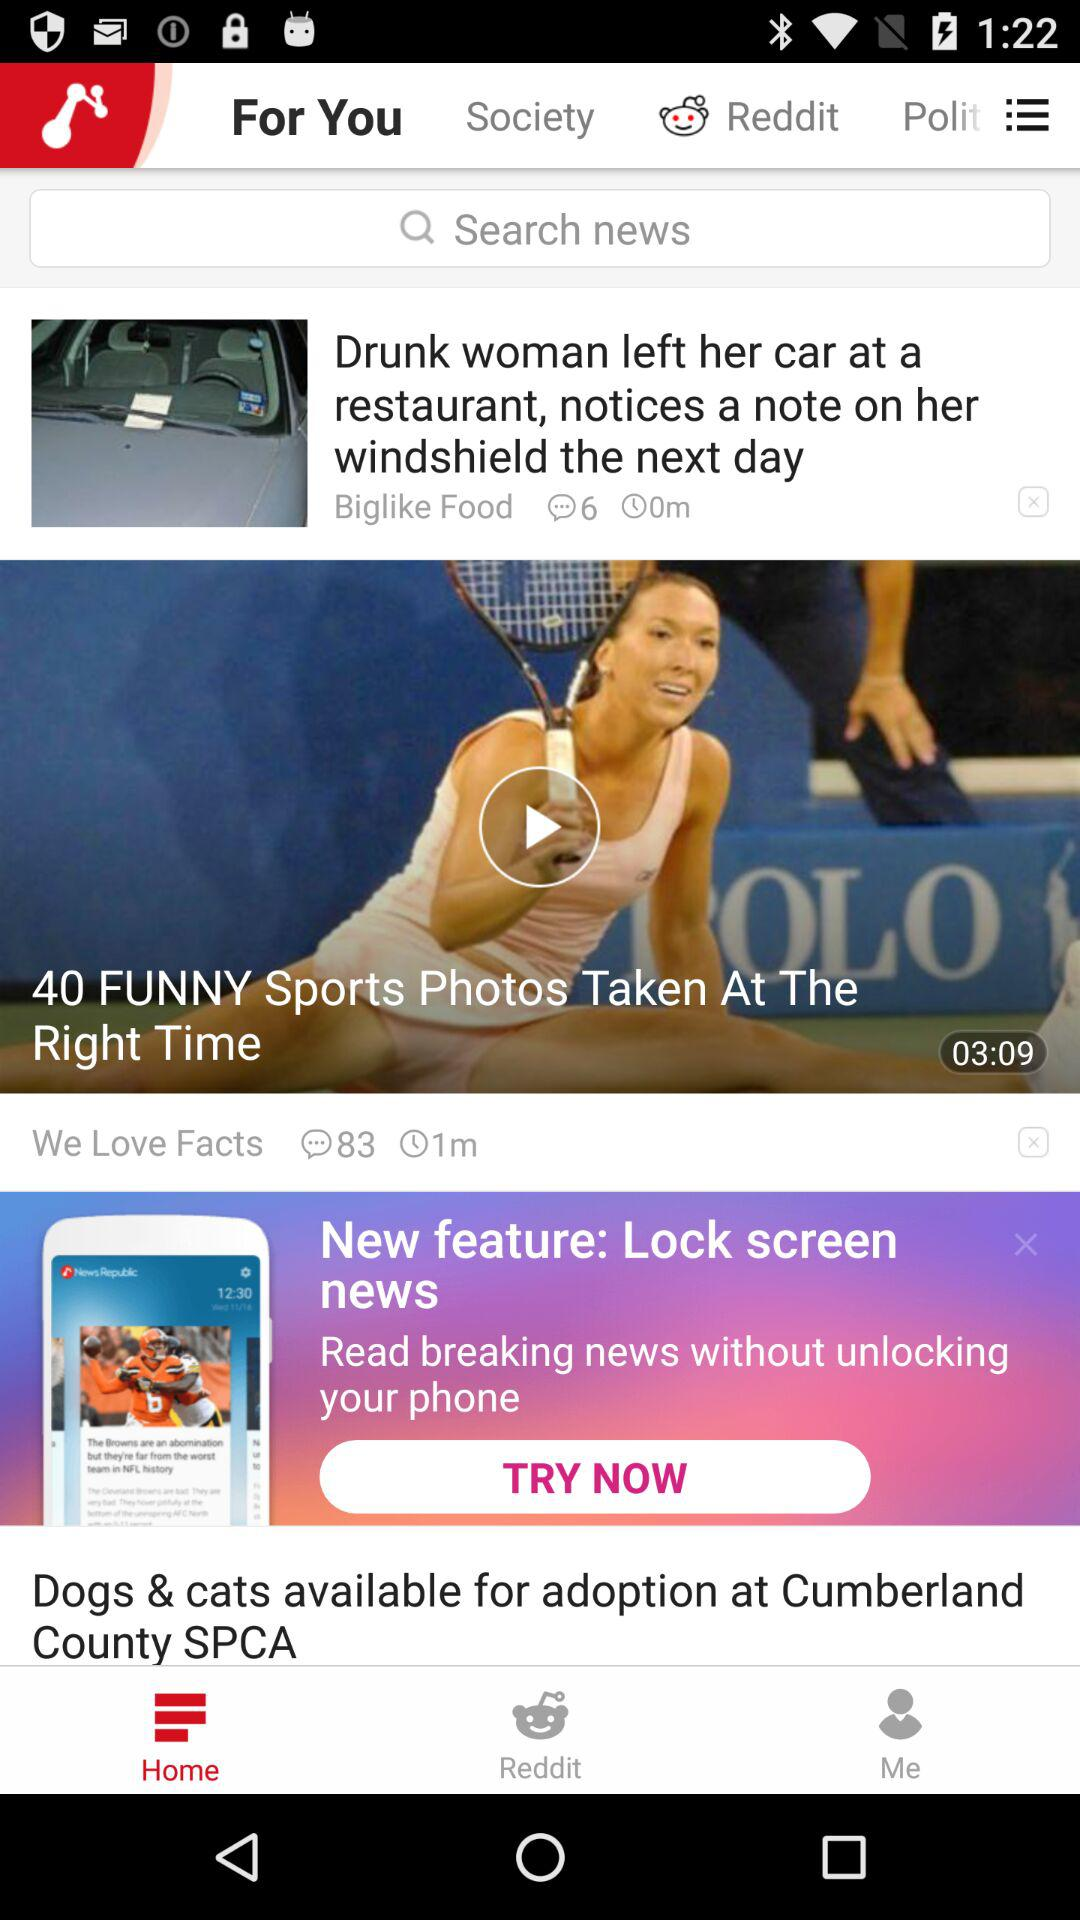How many comments are on the "We Love Facts"? There are 83 comments. 